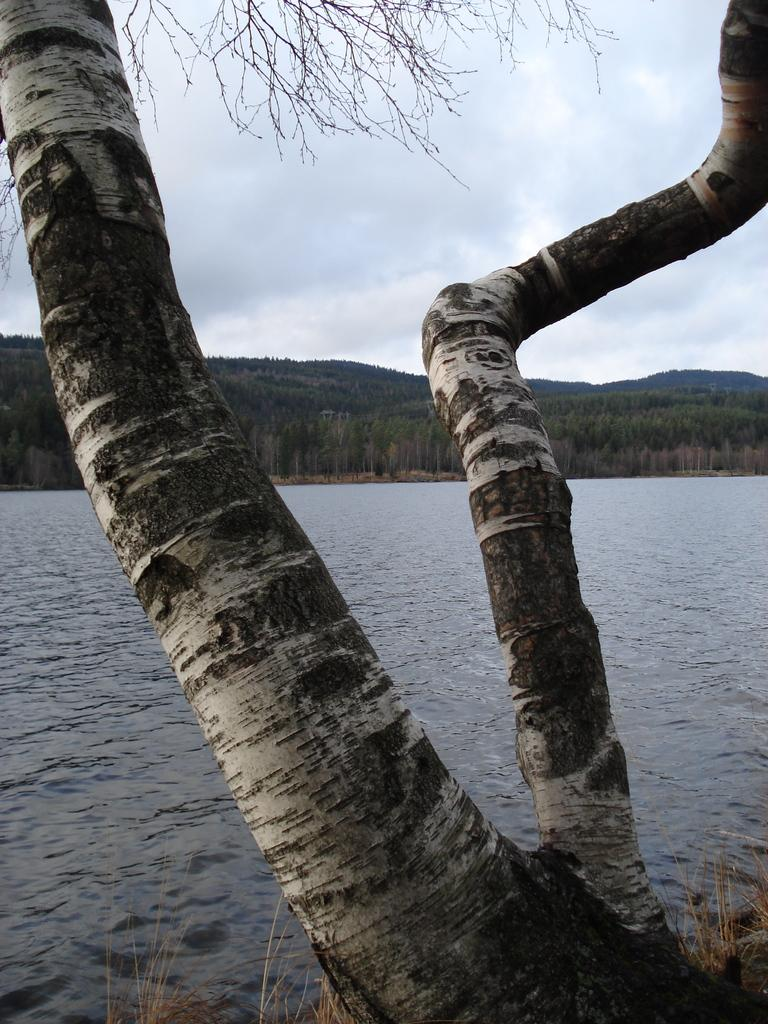What is the main subject in the foreground of the image? There is a tree trunk in the image. What can be seen behind the tree trunk? Water is visible behind the tree trunk. What type of vegetation is visible in the background of the image? There is a group of trees in the background of the image. What type of geographical feature is visible in the farthest in the background? There are mountains in the background of the image. What is visible at the top of the image? The sky is visible at the top of the image. What type of wax is being used to create the observation in the image? There is no wax or observation present in the image; it features a tree trunk, water, a group of trees, mountains, and the sky. 